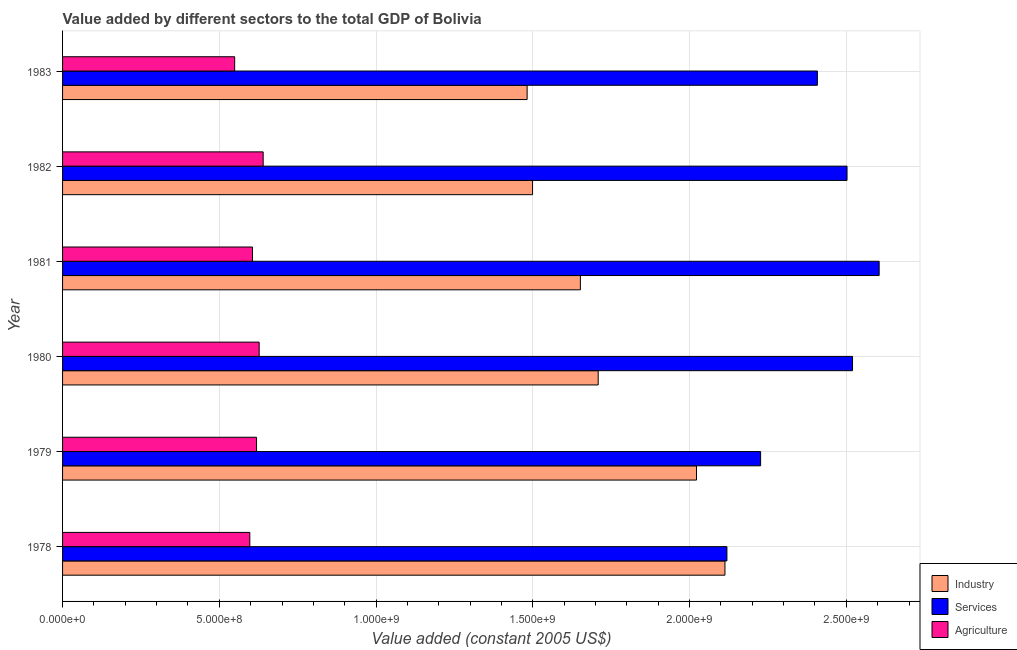How many different coloured bars are there?
Provide a short and direct response. 3. Are the number of bars per tick equal to the number of legend labels?
Provide a succinct answer. Yes. How many bars are there on the 2nd tick from the top?
Provide a succinct answer. 3. What is the value added by agricultural sector in 1979?
Your answer should be very brief. 6.19e+08. Across all years, what is the maximum value added by industrial sector?
Your answer should be very brief. 2.11e+09. Across all years, what is the minimum value added by agricultural sector?
Your answer should be very brief. 5.49e+08. In which year was the value added by services maximum?
Give a very brief answer. 1981. In which year was the value added by services minimum?
Provide a short and direct response. 1978. What is the total value added by services in the graph?
Offer a terse response. 1.44e+1. What is the difference between the value added by industrial sector in 1978 and that in 1981?
Give a very brief answer. 4.61e+08. What is the difference between the value added by agricultural sector in 1980 and the value added by services in 1978?
Your response must be concise. -1.49e+09. What is the average value added by agricultural sector per year?
Offer a very short reply. 6.06e+08. In the year 1981, what is the difference between the value added by industrial sector and value added by agricultural sector?
Your response must be concise. 1.05e+09. In how many years, is the value added by industrial sector greater than 1900000000 US$?
Give a very brief answer. 2. What is the ratio of the value added by services in 1980 to that in 1983?
Your response must be concise. 1.05. Is the value added by industrial sector in 1979 less than that in 1983?
Keep it short and to the point. No. What is the difference between the highest and the second highest value added by agricultural sector?
Your response must be concise. 1.27e+07. What is the difference between the highest and the lowest value added by industrial sector?
Make the answer very short. 6.31e+08. Is the sum of the value added by agricultural sector in 1978 and 1981 greater than the maximum value added by industrial sector across all years?
Your answer should be very brief. No. What does the 2nd bar from the top in 1978 represents?
Provide a short and direct response. Services. What does the 2nd bar from the bottom in 1979 represents?
Keep it short and to the point. Services. Is it the case that in every year, the sum of the value added by industrial sector and value added by services is greater than the value added by agricultural sector?
Ensure brevity in your answer.  Yes. How many bars are there?
Your answer should be very brief. 18. What is the difference between two consecutive major ticks on the X-axis?
Your response must be concise. 5.00e+08. Are the values on the major ticks of X-axis written in scientific E-notation?
Your answer should be compact. Yes. Does the graph contain any zero values?
Ensure brevity in your answer.  No. Does the graph contain grids?
Provide a short and direct response. Yes. How are the legend labels stacked?
Offer a very short reply. Vertical. What is the title of the graph?
Your answer should be very brief. Value added by different sectors to the total GDP of Bolivia. What is the label or title of the X-axis?
Provide a succinct answer. Value added (constant 2005 US$). What is the Value added (constant 2005 US$) of Industry in 1978?
Your answer should be compact. 2.11e+09. What is the Value added (constant 2005 US$) of Services in 1978?
Offer a terse response. 2.12e+09. What is the Value added (constant 2005 US$) of Agriculture in 1978?
Provide a short and direct response. 5.97e+08. What is the Value added (constant 2005 US$) in Industry in 1979?
Offer a very short reply. 2.02e+09. What is the Value added (constant 2005 US$) in Services in 1979?
Your answer should be very brief. 2.23e+09. What is the Value added (constant 2005 US$) of Agriculture in 1979?
Provide a short and direct response. 6.19e+08. What is the Value added (constant 2005 US$) in Industry in 1980?
Your response must be concise. 1.71e+09. What is the Value added (constant 2005 US$) in Services in 1980?
Offer a terse response. 2.52e+09. What is the Value added (constant 2005 US$) of Agriculture in 1980?
Your answer should be compact. 6.27e+08. What is the Value added (constant 2005 US$) in Industry in 1981?
Make the answer very short. 1.65e+09. What is the Value added (constant 2005 US$) in Services in 1981?
Provide a succinct answer. 2.60e+09. What is the Value added (constant 2005 US$) in Agriculture in 1981?
Offer a very short reply. 6.06e+08. What is the Value added (constant 2005 US$) of Industry in 1982?
Give a very brief answer. 1.50e+09. What is the Value added (constant 2005 US$) of Services in 1982?
Provide a short and direct response. 2.50e+09. What is the Value added (constant 2005 US$) of Agriculture in 1982?
Make the answer very short. 6.40e+08. What is the Value added (constant 2005 US$) of Industry in 1983?
Your answer should be very brief. 1.48e+09. What is the Value added (constant 2005 US$) of Services in 1983?
Ensure brevity in your answer.  2.41e+09. What is the Value added (constant 2005 US$) in Agriculture in 1983?
Keep it short and to the point. 5.49e+08. Across all years, what is the maximum Value added (constant 2005 US$) of Industry?
Your answer should be very brief. 2.11e+09. Across all years, what is the maximum Value added (constant 2005 US$) of Services?
Give a very brief answer. 2.60e+09. Across all years, what is the maximum Value added (constant 2005 US$) in Agriculture?
Your response must be concise. 6.40e+08. Across all years, what is the minimum Value added (constant 2005 US$) in Industry?
Make the answer very short. 1.48e+09. Across all years, what is the minimum Value added (constant 2005 US$) in Services?
Ensure brevity in your answer.  2.12e+09. Across all years, what is the minimum Value added (constant 2005 US$) of Agriculture?
Provide a short and direct response. 5.49e+08. What is the total Value added (constant 2005 US$) of Industry in the graph?
Your answer should be very brief. 1.05e+1. What is the total Value added (constant 2005 US$) in Services in the graph?
Provide a short and direct response. 1.44e+1. What is the total Value added (constant 2005 US$) of Agriculture in the graph?
Provide a short and direct response. 3.64e+09. What is the difference between the Value added (constant 2005 US$) of Industry in 1978 and that in 1979?
Offer a terse response. 9.07e+07. What is the difference between the Value added (constant 2005 US$) in Services in 1978 and that in 1979?
Ensure brevity in your answer.  -1.07e+08. What is the difference between the Value added (constant 2005 US$) in Agriculture in 1978 and that in 1979?
Make the answer very short. -2.15e+07. What is the difference between the Value added (constant 2005 US$) of Industry in 1978 and that in 1980?
Provide a succinct answer. 4.04e+08. What is the difference between the Value added (constant 2005 US$) of Services in 1978 and that in 1980?
Your answer should be compact. -4.01e+08. What is the difference between the Value added (constant 2005 US$) of Agriculture in 1978 and that in 1980?
Your answer should be very brief. -2.98e+07. What is the difference between the Value added (constant 2005 US$) of Industry in 1978 and that in 1981?
Provide a short and direct response. 4.61e+08. What is the difference between the Value added (constant 2005 US$) in Services in 1978 and that in 1981?
Your answer should be compact. -4.86e+08. What is the difference between the Value added (constant 2005 US$) in Agriculture in 1978 and that in 1981?
Give a very brief answer. -8.59e+06. What is the difference between the Value added (constant 2005 US$) of Industry in 1978 and that in 1982?
Keep it short and to the point. 6.14e+08. What is the difference between the Value added (constant 2005 US$) in Services in 1978 and that in 1982?
Your answer should be very brief. -3.83e+08. What is the difference between the Value added (constant 2005 US$) of Agriculture in 1978 and that in 1982?
Keep it short and to the point. -4.26e+07. What is the difference between the Value added (constant 2005 US$) in Industry in 1978 and that in 1983?
Keep it short and to the point. 6.31e+08. What is the difference between the Value added (constant 2005 US$) in Services in 1978 and that in 1983?
Offer a terse response. -2.89e+08. What is the difference between the Value added (constant 2005 US$) in Agriculture in 1978 and that in 1983?
Offer a very short reply. 4.83e+07. What is the difference between the Value added (constant 2005 US$) in Industry in 1979 and that in 1980?
Your answer should be compact. 3.14e+08. What is the difference between the Value added (constant 2005 US$) in Services in 1979 and that in 1980?
Offer a very short reply. -2.93e+08. What is the difference between the Value added (constant 2005 US$) of Agriculture in 1979 and that in 1980?
Make the answer very short. -8.37e+06. What is the difference between the Value added (constant 2005 US$) in Industry in 1979 and that in 1981?
Offer a very short reply. 3.70e+08. What is the difference between the Value added (constant 2005 US$) in Services in 1979 and that in 1981?
Your response must be concise. -3.78e+08. What is the difference between the Value added (constant 2005 US$) of Agriculture in 1979 and that in 1981?
Provide a succinct answer. 1.29e+07. What is the difference between the Value added (constant 2005 US$) of Industry in 1979 and that in 1982?
Offer a terse response. 5.23e+08. What is the difference between the Value added (constant 2005 US$) in Services in 1979 and that in 1982?
Your answer should be very brief. -2.76e+08. What is the difference between the Value added (constant 2005 US$) in Agriculture in 1979 and that in 1982?
Your answer should be compact. -2.11e+07. What is the difference between the Value added (constant 2005 US$) in Industry in 1979 and that in 1983?
Your answer should be very brief. 5.40e+08. What is the difference between the Value added (constant 2005 US$) of Services in 1979 and that in 1983?
Give a very brief answer. -1.81e+08. What is the difference between the Value added (constant 2005 US$) in Agriculture in 1979 and that in 1983?
Your answer should be compact. 6.98e+07. What is the difference between the Value added (constant 2005 US$) in Industry in 1980 and that in 1981?
Provide a succinct answer. 5.68e+07. What is the difference between the Value added (constant 2005 US$) in Services in 1980 and that in 1981?
Your answer should be very brief. -8.49e+07. What is the difference between the Value added (constant 2005 US$) in Agriculture in 1980 and that in 1981?
Make the answer very short. 2.12e+07. What is the difference between the Value added (constant 2005 US$) of Industry in 1980 and that in 1982?
Your answer should be very brief. 2.09e+08. What is the difference between the Value added (constant 2005 US$) in Services in 1980 and that in 1982?
Keep it short and to the point. 1.76e+07. What is the difference between the Value added (constant 2005 US$) of Agriculture in 1980 and that in 1982?
Your answer should be very brief. -1.27e+07. What is the difference between the Value added (constant 2005 US$) of Industry in 1980 and that in 1983?
Ensure brevity in your answer.  2.27e+08. What is the difference between the Value added (constant 2005 US$) of Services in 1980 and that in 1983?
Give a very brief answer. 1.12e+08. What is the difference between the Value added (constant 2005 US$) of Agriculture in 1980 and that in 1983?
Provide a succinct answer. 7.81e+07. What is the difference between the Value added (constant 2005 US$) in Industry in 1981 and that in 1982?
Provide a succinct answer. 1.53e+08. What is the difference between the Value added (constant 2005 US$) in Services in 1981 and that in 1982?
Ensure brevity in your answer.  1.03e+08. What is the difference between the Value added (constant 2005 US$) in Agriculture in 1981 and that in 1982?
Provide a succinct answer. -3.40e+07. What is the difference between the Value added (constant 2005 US$) of Industry in 1981 and that in 1983?
Provide a short and direct response. 1.70e+08. What is the difference between the Value added (constant 2005 US$) in Services in 1981 and that in 1983?
Offer a terse response. 1.97e+08. What is the difference between the Value added (constant 2005 US$) of Agriculture in 1981 and that in 1983?
Offer a very short reply. 5.69e+07. What is the difference between the Value added (constant 2005 US$) of Industry in 1982 and that in 1983?
Offer a terse response. 1.73e+07. What is the difference between the Value added (constant 2005 US$) in Services in 1982 and that in 1983?
Keep it short and to the point. 9.46e+07. What is the difference between the Value added (constant 2005 US$) in Agriculture in 1982 and that in 1983?
Make the answer very short. 9.09e+07. What is the difference between the Value added (constant 2005 US$) of Industry in 1978 and the Value added (constant 2005 US$) of Services in 1979?
Make the answer very short. -1.14e+08. What is the difference between the Value added (constant 2005 US$) in Industry in 1978 and the Value added (constant 2005 US$) in Agriculture in 1979?
Provide a succinct answer. 1.49e+09. What is the difference between the Value added (constant 2005 US$) of Services in 1978 and the Value added (constant 2005 US$) of Agriculture in 1979?
Your answer should be very brief. 1.50e+09. What is the difference between the Value added (constant 2005 US$) of Industry in 1978 and the Value added (constant 2005 US$) of Services in 1980?
Your response must be concise. -4.07e+08. What is the difference between the Value added (constant 2005 US$) of Industry in 1978 and the Value added (constant 2005 US$) of Agriculture in 1980?
Your answer should be compact. 1.49e+09. What is the difference between the Value added (constant 2005 US$) in Services in 1978 and the Value added (constant 2005 US$) in Agriculture in 1980?
Provide a succinct answer. 1.49e+09. What is the difference between the Value added (constant 2005 US$) of Industry in 1978 and the Value added (constant 2005 US$) of Services in 1981?
Provide a succinct answer. -4.92e+08. What is the difference between the Value added (constant 2005 US$) in Industry in 1978 and the Value added (constant 2005 US$) in Agriculture in 1981?
Give a very brief answer. 1.51e+09. What is the difference between the Value added (constant 2005 US$) of Services in 1978 and the Value added (constant 2005 US$) of Agriculture in 1981?
Provide a short and direct response. 1.51e+09. What is the difference between the Value added (constant 2005 US$) in Industry in 1978 and the Value added (constant 2005 US$) in Services in 1982?
Ensure brevity in your answer.  -3.89e+08. What is the difference between the Value added (constant 2005 US$) in Industry in 1978 and the Value added (constant 2005 US$) in Agriculture in 1982?
Offer a terse response. 1.47e+09. What is the difference between the Value added (constant 2005 US$) in Services in 1978 and the Value added (constant 2005 US$) in Agriculture in 1982?
Provide a short and direct response. 1.48e+09. What is the difference between the Value added (constant 2005 US$) of Industry in 1978 and the Value added (constant 2005 US$) of Services in 1983?
Your response must be concise. -2.95e+08. What is the difference between the Value added (constant 2005 US$) in Industry in 1978 and the Value added (constant 2005 US$) in Agriculture in 1983?
Make the answer very short. 1.56e+09. What is the difference between the Value added (constant 2005 US$) in Services in 1978 and the Value added (constant 2005 US$) in Agriculture in 1983?
Make the answer very short. 1.57e+09. What is the difference between the Value added (constant 2005 US$) in Industry in 1979 and the Value added (constant 2005 US$) in Services in 1980?
Give a very brief answer. -4.98e+08. What is the difference between the Value added (constant 2005 US$) in Industry in 1979 and the Value added (constant 2005 US$) in Agriculture in 1980?
Provide a short and direct response. 1.39e+09. What is the difference between the Value added (constant 2005 US$) in Services in 1979 and the Value added (constant 2005 US$) in Agriculture in 1980?
Your answer should be compact. 1.60e+09. What is the difference between the Value added (constant 2005 US$) in Industry in 1979 and the Value added (constant 2005 US$) in Services in 1981?
Provide a short and direct response. -5.83e+08. What is the difference between the Value added (constant 2005 US$) in Industry in 1979 and the Value added (constant 2005 US$) in Agriculture in 1981?
Ensure brevity in your answer.  1.42e+09. What is the difference between the Value added (constant 2005 US$) of Services in 1979 and the Value added (constant 2005 US$) of Agriculture in 1981?
Provide a succinct answer. 1.62e+09. What is the difference between the Value added (constant 2005 US$) of Industry in 1979 and the Value added (constant 2005 US$) of Services in 1982?
Your answer should be compact. -4.80e+08. What is the difference between the Value added (constant 2005 US$) of Industry in 1979 and the Value added (constant 2005 US$) of Agriculture in 1982?
Your response must be concise. 1.38e+09. What is the difference between the Value added (constant 2005 US$) in Services in 1979 and the Value added (constant 2005 US$) in Agriculture in 1982?
Keep it short and to the point. 1.59e+09. What is the difference between the Value added (constant 2005 US$) in Industry in 1979 and the Value added (constant 2005 US$) in Services in 1983?
Keep it short and to the point. -3.86e+08. What is the difference between the Value added (constant 2005 US$) of Industry in 1979 and the Value added (constant 2005 US$) of Agriculture in 1983?
Ensure brevity in your answer.  1.47e+09. What is the difference between the Value added (constant 2005 US$) of Services in 1979 and the Value added (constant 2005 US$) of Agriculture in 1983?
Provide a succinct answer. 1.68e+09. What is the difference between the Value added (constant 2005 US$) in Industry in 1980 and the Value added (constant 2005 US$) in Services in 1981?
Provide a short and direct response. -8.96e+08. What is the difference between the Value added (constant 2005 US$) in Industry in 1980 and the Value added (constant 2005 US$) in Agriculture in 1981?
Your answer should be compact. 1.10e+09. What is the difference between the Value added (constant 2005 US$) in Services in 1980 and the Value added (constant 2005 US$) in Agriculture in 1981?
Ensure brevity in your answer.  1.91e+09. What is the difference between the Value added (constant 2005 US$) in Industry in 1980 and the Value added (constant 2005 US$) in Services in 1982?
Give a very brief answer. -7.94e+08. What is the difference between the Value added (constant 2005 US$) of Industry in 1980 and the Value added (constant 2005 US$) of Agriculture in 1982?
Make the answer very short. 1.07e+09. What is the difference between the Value added (constant 2005 US$) of Services in 1980 and the Value added (constant 2005 US$) of Agriculture in 1982?
Your answer should be compact. 1.88e+09. What is the difference between the Value added (constant 2005 US$) in Industry in 1980 and the Value added (constant 2005 US$) in Services in 1983?
Give a very brief answer. -6.99e+08. What is the difference between the Value added (constant 2005 US$) of Industry in 1980 and the Value added (constant 2005 US$) of Agriculture in 1983?
Offer a terse response. 1.16e+09. What is the difference between the Value added (constant 2005 US$) in Services in 1980 and the Value added (constant 2005 US$) in Agriculture in 1983?
Ensure brevity in your answer.  1.97e+09. What is the difference between the Value added (constant 2005 US$) of Industry in 1981 and the Value added (constant 2005 US$) of Services in 1982?
Your answer should be very brief. -8.51e+08. What is the difference between the Value added (constant 2005 US$) of Industry in 1981 and the Value added (constant 2005 US$) of Agriculture in 1982?
Provide a succinct answer. 1.01e+09. What is the difference between the Value added (constant 2005 US$) of Services in 1981 and the Value added (constant 2005 US$) of Agriculture in 1982?
Offer a terse response. 1.96e+09. What is the difference between the Value added (constant 2005 US$) in Industry in 1981 and the Value added (constant 2005 US$) in Services in 1983?
Provide a short and direct response. -7.56e+08. What is the difference between the Value added (constant 2005 US$) in Industry in 1981 and the Value added (constant 2005 US$) in Agriculture in 1983?
Provide a succinct answer. 1.10e+09. What is the difference between the Value added (constant 2005 US$) in Services in 1981 and the Value added (constant 2005 US$) in Agriculture in 1983?
Offer a very short reply. 2.06e+09. What is the difference between the Value added (constant 2005 US$) in Industry in 1982 and the Value added (constant 2005 US$) in Services in 1983?
Offer a very short reply. -9.09e+08. What is the difference between the Value added (constant 2005 US$) of Industry in 1982 and the Value added (constant 2005 US$) of Agriculture in 1983?
Your answer should be compact. 9.50e+08. What is the difference between the Value added (constant 2005 US$) of Services in 1982 and the Value added (constant 2005 US$) of Agriculture in 1983?
Give a very brief answer. 1.95e+09. What is the average Value added (constant 2005 US$) in Industry per year?
Ensure brevity in your answer.  1.75e+09. What is the average Value added (constant 2005 US$) in Services per year?
Your answer should be very brief. 2.40e+09. What is the average Value added (constant 2005 US$) of Agriculture per year?
Offer a terse response. 6.06e+08. In the year 1978, what is the difference between the Value added (constant 2005 US$) of Industry and Value added (constant 2005 US$) of Services?
Your response must be concise. -6.31e+06. In the year 1978, what is the difference between the Value added (constant 2005 US$) of Industry and Value added (constant 2005 US$) of Agriculture?
Ensure brevity in your answer.  1.52e+09. In the year 1978, what is the difference between the Value added (constant 2005 US$) in Services and Value added (constant 2005 US$) in Agriculture?
Your answer should be very brief. 1.52e+09. In the year 1979, what is the difference between the Value added (constant 2005 US$) of Industry and Value added (constant 2005 US$) of Services?
Your answer should be compact. -2.05e+08. In the year 1979, what is the difference between the Value added (constant 2005 US$) of Industry and Value added (constant 2005 US$) of Agriculture?
Offer a terse response. 1.40e+09. In the year 1979, what is the difference between the Value added (constant 2005 US$) in Services and Value added (constant 2005 US$) in Agriculture?
Keep it short and to the point. 1.61e+09. In the year 1980, what is the difference between the Value added (constant 2005 US$) of Industry and Value added (constant 2005 US$) of Services?
Make the answer very short. -8.11e+08. In the year 1980, what is the difference between the Value added (constant 2005 US$) of Industry and Value added (constant 2005 US$) of Agriculture?
Provide a succinct answer. 1.08e+09. In the year 1980, what is the difference between the Value added (constant 2005 US$) of Services and Value added (constant 2005 US$) of Agriculture?
Make the answer very short. 1.89e+09. In the year 1981, what is the difference between the Value added (constant 2005 US$) of Industry and Value added (constant 2005 US$) of Services?
Your answer should be compact. -9.53e+08. In the year 1981, what is the difference between the Value added (constant 2005 US$) of Industry and Value added (constant 2005 US$) of Agriculture?
Give a very brief answer. 1.05e+09. In the year 1981, what is the difference between the Value added (constant 2005 US$) in Services and Value added (constant 2005 US$) in Agriculture?
Offer a terse response. 2.00e+09. In the year 1982, what is the difference between the Value added (constant 2005 US$) of Industry and Value added (constant 2005 US$) of Services?
Give a very brief answer. -1.00e+09. In the year 1982, what is the difference between the Value added (constant 2005 US$) of Industry and Value added (constant 2005 US$) of Agriculture?
Your answer should be very brief. 8.59e+08. In the year 1982, what is the difference between the Value added (constant 2005 US$) of Services and Value added (constant 2005 US$) of Agriculture?
Provide a short and direct response. 1.86e+09. In the year 1983, what is the difference between the Value added (constant 2005 US$) of Industry and Value added (constant 2005 US$) of Services?
Your answer should be very brief. -9.26e+08. In the year 1983, what is the difference between the Value added (constant 2005 US$) in Industry and Value added (constant 2005 US$) in Agriculture?
Make the answer very short. 9.33e+08. In the year 1983, what is the difference between the Value added (constant 2005 US$) of Services and Value added (constant 2005 US$) of Agriculture?
Keep it short and to the point. 1.86e+09. What is the ratio of the Value added (constant 2005 US$) of Industry in 1978 to that in 1979?
Provide a short and direct response. 1.04. What is the ratio of the Value added (constant 2005 US$) of Services in 1978 to that in 1979?
Offer a terse response. 0.95. What is the ratio of the Value added (constant 2005 US$) of Agriculture in 1978 to that in 1979?
Offer a very short reply. 0.97. What is the ratio of the Value added (constant 2005 US$) of Industry in 1978 to that in 1980?
Give a very brief answer. 1.24. What is the ratio of the Value added (constant 2005 US$) in Services in 1978 to that in 1980?
Offer a very short reply. 0.84. What is the ratio of the Value added (constant 2005 US$) of Agriculture in 1978 to that in 1980?
Give a very brief answer. 0.95. What is the ratio of the Value added (constant 2005 US$) of Industry in 1978 to that in 1981?
Offer a terse response. 1.28. What is the ratio of the Value added (constant 2005 US$) in Services in 1978 to that in 1981?
Offer a very short reply. 0.81. What is the ratio of the Value added (constant 2005 US$) in Agriculture in 1978 to that in 1981?
Give a very brief answer. 0.99. What is the ratio of the Value added (constant 2005 US$) of Industry in 1978 to that in 1982?
Provide a succinct answer. 1.41. What is the ratio of the Value added (constant 2005 US$) in Services in 1978 to that in 1982?
Provide a succinct answer. 0.85. What is the ratio of the Value added (constant 2005 US$) in Agriculture in 1978 to that in 1982?
Ensure brevity in your answer.  0.93. What is the ratio of the Value added (constant 2005 US$) in Industry in 1978 to that in 1983?
Provide a short and direct response. 1.43. What is the ratio of the Value added (constant 2005 US$) of Services in 1978 to that in 1983?
Ensure brevity in your answer.  0.88. What is the ratio of the Value added (constant 2005 US$) in Agriculture in 1978 to that in 1983?
Make the answer very short. 1.09. What is the ratio of the Value added (constant 2005 US$) in Industry in 1979 to that in 1980?
Offer a very short reply. 1.18. What is the ratio of the Value added (constant 2005 US$) of Services in 1979 to that in 1980?
Ensure brevity in your answer.  0.88. What is the ratio of the Value added (constant 2005 US$) in Agriculture in 1979 to that in 1980?
Keep it short and to the point. 0.99. What is the ratio of the Value added (constant 2005 US$) of Industry in 1979 to that in 1981?
Provide a succinct answer. 1.22. What is the ratio of the Value added (constant 2005 US$) in Services in 1979 to that in 1981?
Provide a succinct answer. 0.85. What is the ratio of the Value added (constant 2005 US$) of Agriculture in 1979 to that in 1981?
Make the answer very short. 1.02. What is the ratio of the Value added (constant 2005 US$) of Industry in 1979 to that in 1982?
Provide a short and direct response. 1.35. What is the ratio of the Value added (constant 2005 US$) in Services in 1979 to that in 1982?
Offer a terse response. 0.89. What is the ratio of the Value added (constant 2005 US$) in Industry in 1979 to that in 1983?
Offer a terse response. 1.36. What is the ratio of the Value added (constant 2005 US$) of Services in 1979 to that in 1983?
Offer a very short reply. 0.92. What is the ratio of the Value added (constant 2005 US$) in Agriculture in 1979 to that in 1983?
Keep it short and to the point. 1.13. What is the ratio of the Value added (constant 2005 US$) in Industry in 1980 to that in 1981?
Keep it short and to the point. 1.03. What is the ratio of the Value added (constant 2005 US$) in Services in 1980 to that in 1981?
Your answer should be compact. 0.97. What is the ratio of the Value added (constant 2005 US$) of Agriculture in 1980 to that in 1981?
Your answer should be very brief. 1.03. What is the ratio of the Value added (constant 2005 US$) of Industry in 1980 to that in 1982?
Keep it short and to the point. 1.14. What is the ratio of the Value added (constant 2005 US$) in Agriculture in 1980 to that in 1982?
Keep it short and to the point. 0.98. What is the ratio of the Value added (constant 2005 US$) of Industry in 1980 to that in 1983?
Offer a very short reply. 1.15. What is the ratio of the Value added (constant 2005 US$) in Services in 1980 to that in 1983?
Offer a very short reply. 1.05. What is the ratio of the Value added (constant 2005 US$) in Agriculture in 1980 to that in 1983?
Ensure brevity in your answer.  1.14. What is the ratio of the Value added (constant 2005 US$) in Industry in 1981 to that in 1982?
Provide a short and direct response. 1.1. What is the ratio of the Value added (constant 2005 US$) of Services in 1981 to that in 1982?
Offer a very short reply. 1.04. What is the ratio of the Value added (constant 2005 US$) of Agriculture in 1981 to that in 1982?
Offer a terse response. 0.95. What is the ratio of the Value added (constant 2005 US$) of Industry in 1981 to that in 1983?
Provide a short and direct response. 1.11. What is the ratio of the Value added (constant 2005 US$) of Services in 1981 to that in 1983?
Make the answer very short. 1.08. What is the ratio of the Value added (constant 2005 US$) in Agriculture in 1981 to that in 1983?
Keep it short and to the point. 1.1. What is the ratio of the Value added (constant 2005 US$) of Industry in 1982 to that in 1983?
Provide a short and direct response. 1.01. What is the ratio of the Value added (constant 2005 US$) of Services in 1982 to that in 1983?
Your answer should be very brief. 1.04. What is the ratio of the Value added (constant 2005 US$) in Agriculture in 1982 to that in 1983?
Make the answer very short. 1.17. What is the difference between the highest and the second highest Value added (constant 2005 US$) in Industry?
Keep it short and to the point. 9.07e+07. What is the difference between the highest and the second highest Value added (constant 2005 US$) in Services?
Offer a terse response. 8.49e+07. What is the difference between the highest and the second highest Value added (constant 2005 US$) in Agriculture?
Give a very brief answer. 1.27e+07. What is the difference between the highest and the lowest Value added (constant 2005 US$) of Industry?
Offer a very short reply. 6.31e+08. What is the difference between the highest and the lowest Value added (constant 2005 US$) in Services?
Provide a succinct answer. 4.86e+08. What is the difference between the highest and the lowest Value added (constant 2005 US$) of Agriculture?
Give a very brief answer. 9.09e+07. 